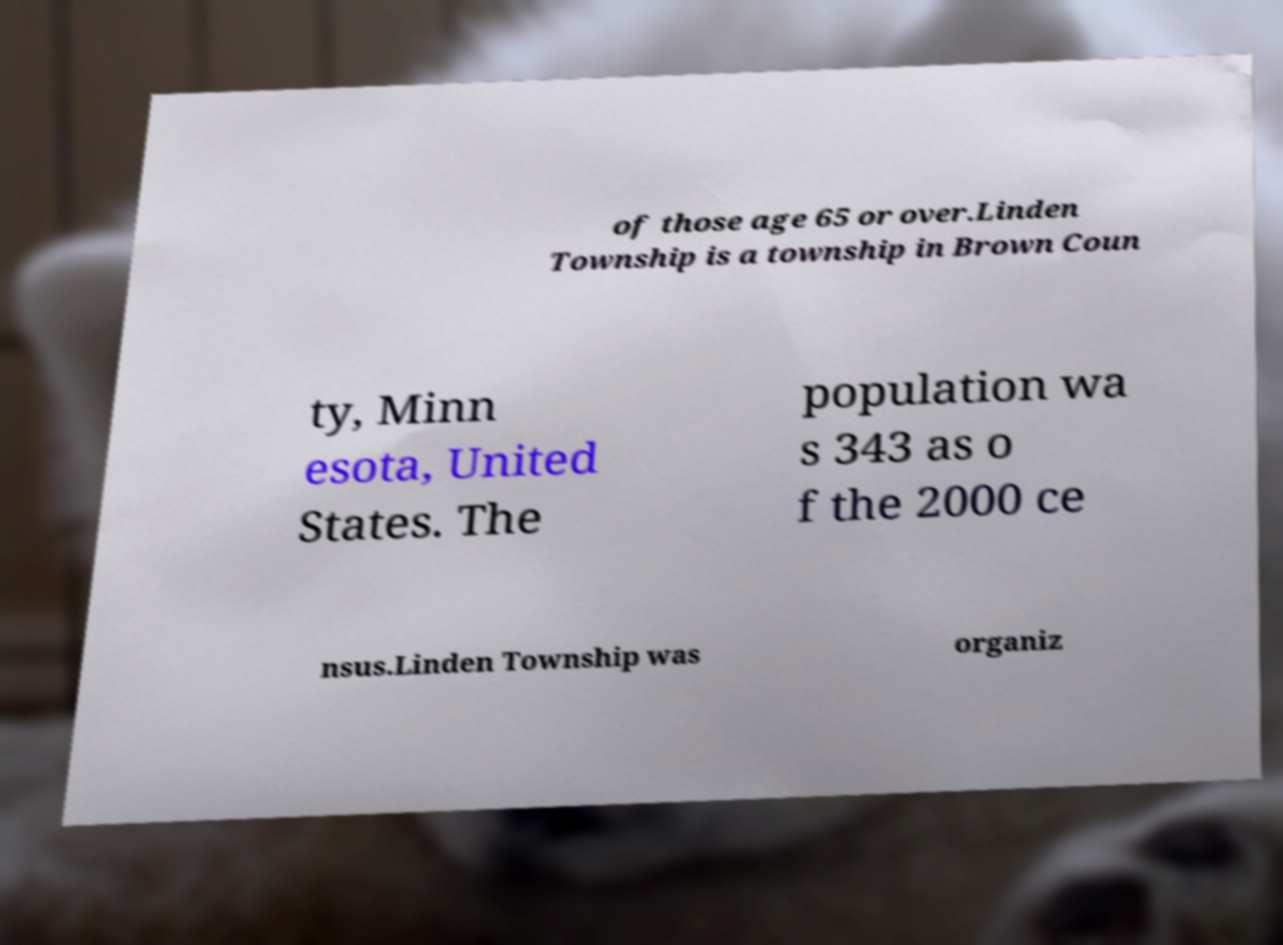Please read and relay the text visible in this image. What does it say? of those age 65 or over.Linden Township is a township in Brown Coun ty, Minn esota, United States. The population wa s 343 as o f the 2000 ce nsus.Linden Township was organiz 